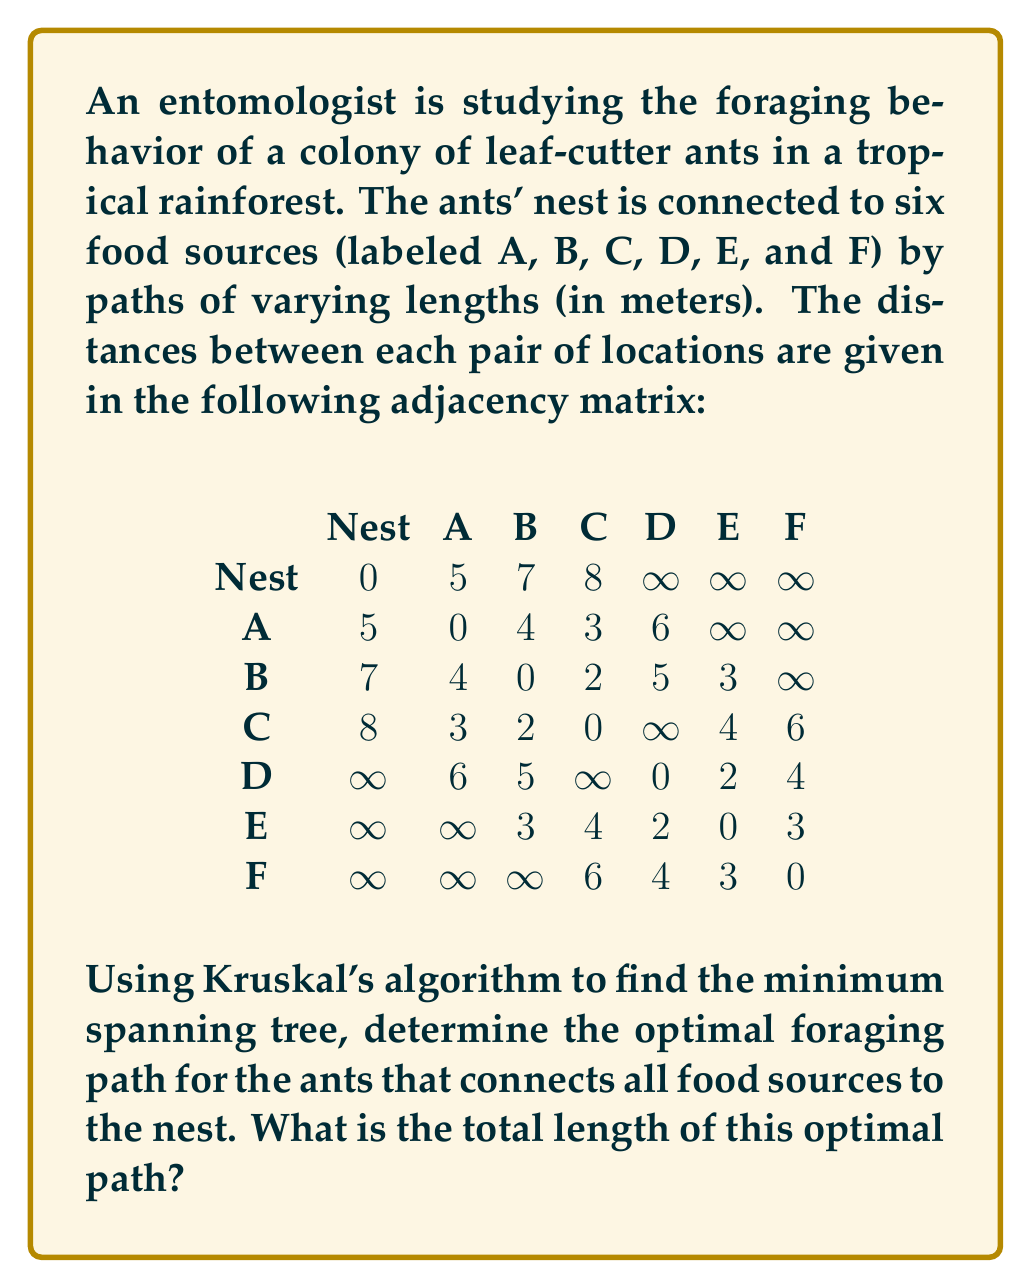Give your solution to this math problem. To solve this problem, we'll use Kruskal's algorithm to find the minimum spanning tree (MST) of the graph representing the ants' foraging network. This will give us the optimal path connecting all food sources to the nest with the minimum total distance.

Steps:

1) First, list all edges in order of increasing weight:
   B-C (2), D-E (2), A-C (3), B-E (3), E-F (3), A-B (4), C-E (4), D-F (4), Nest-A (5), B-D (5), C-F (6), A-D (6), Nest-B (7), Nest-C (8)

2) Start with an empty set of edges and add edges one by one, smallest first, skipping any that would create a cycle:

   - Add B-C (2)
   - Add D-E (2)
   - Add A-C (3)
   - Add B-E (3)
   - Add E-F (3)
   - Skip A-B (4) as it would create a cycle
   - Skip C-E (4) as it would create a cycle
   - Skip D-F (4) as it would create a cycle
   - Add Nest-A (5)

3) At this point, we have added 6 edges, which is exactly what we need for a minimum spanning tree with 7 vertices (Nest + 6 food sources).

4) The resulting minimum spanning tree consists of these edges:
   B-C (2), D-E (2), A-C (3), B-E (3), E-F (3), Nest-A (5)

5) To calculate the total length of the optimal path, sum the weights of these edges:
   2 + 2 + 3 + 3 + 3 + 5 = 18

Therefore, the optimal foraging path for the ants has a total length of 18 meters.
Answer: The total length of the optimal foraging path is 18 meters. 